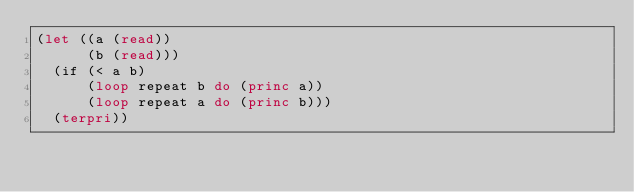Convert code to text. <code><loc_0><loc_0><loc_500><loc_500><_Lisp_>(let ((a (read))
      (b (read)))
  (if (< a b)
      (loop repeat b do (princ a))
      (loop repeat a do (princ b)))
  (terpri))</code> 